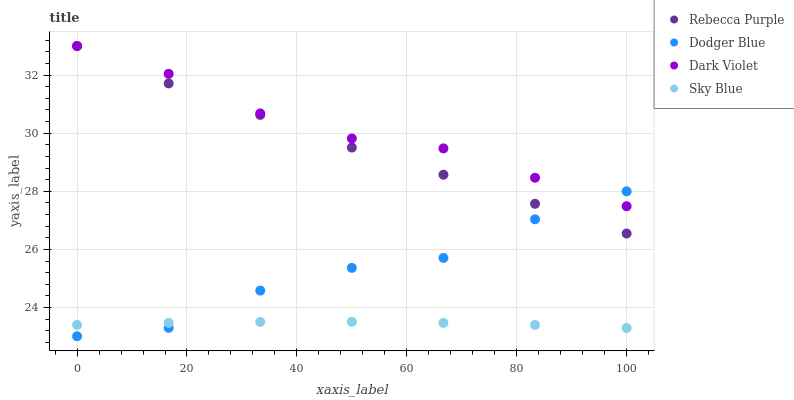Does Sky Blue have the minimum area under the curve?
Answer yes or no. Yes. Does Dark Violet have the maximum area under the curve?
Answer yes or no. Yes. Does Dodger Blue have the minimum area under the curve?
Answer yes or no. No. Does Dodger Blue have the maximum area under the curve?
Answer yes or no. No. Is Sky Blue the smoothest?
Answer yes or no. Yes. Is Dodger Blue the roughest?
Answer yes or no. Yes. Is Rebecca Purple the smoothest?
Answer yes or no. No. Is Rebecca Purple the roughest?
Answer yes or no. No. Does Dodger Blue have the lowest value?
Answer yes or no. Yes. Does Rebecca Purple have the lowest value?
Answer yes or no. No. Does Dark Violet have the highest value?
Answer yes or no. Yes. Does Dodger Blue have the highest value?
Answer yes or no. No. Is Sky Blue less than Rebecca Purple?
Answer yes or no. Yes. Is Dark Violet greater than Sky Blue?
Answer yes or no. Yes. Does Dark Violet intersect Rebecca Purple?
Answer yes or no. Yes. Is Dark Violet less than Rebecca Purple?
Answer yes or no. No. Is Dark Violet greater than Rebecca Purple?
Answer yes or no. No. Does Sky Blue intersect Rebecca Purple?
Answer yes or no. No. 